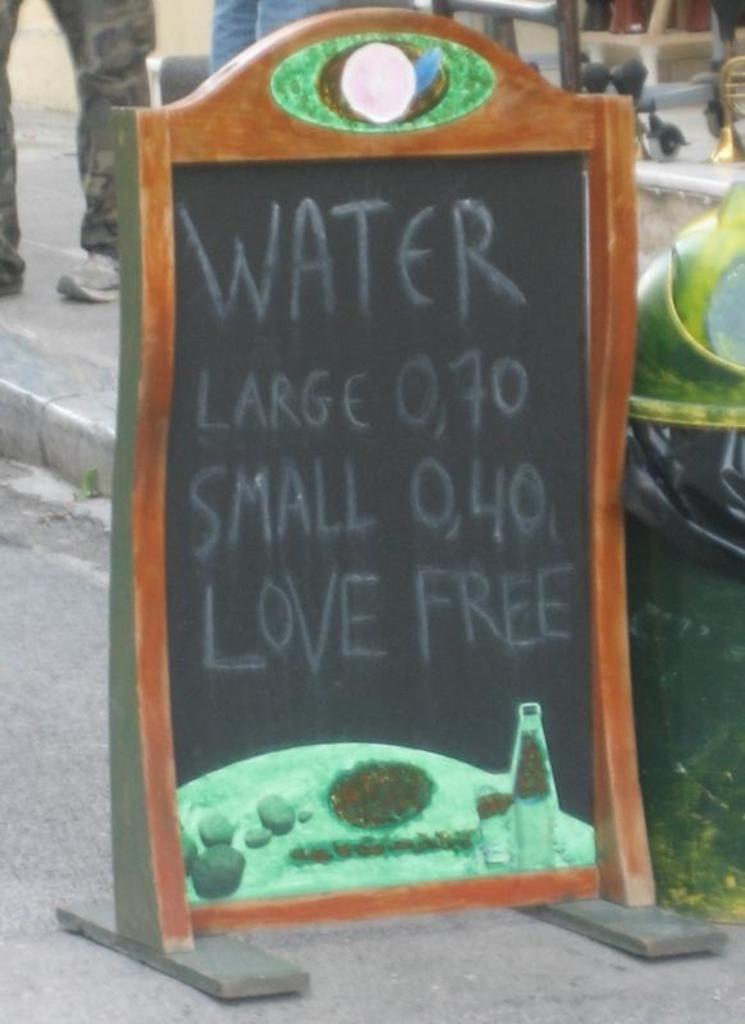What is the main object in the image? There is a board with letters in the image. What is the purpose of the board? The board is likely a dustbin, as it has letters on it. Can you describe the people in the background of the image? There are two people standing in the background of the image. What type of ship can be seen sailing in the background of the image? There is no ship visible in the image; it only features a board with letters and two people standing in the background. What shape is the knife that is being used by one of the people in the image? There is no knife present in the image; it only features a board with letters and two people standing in the background. 